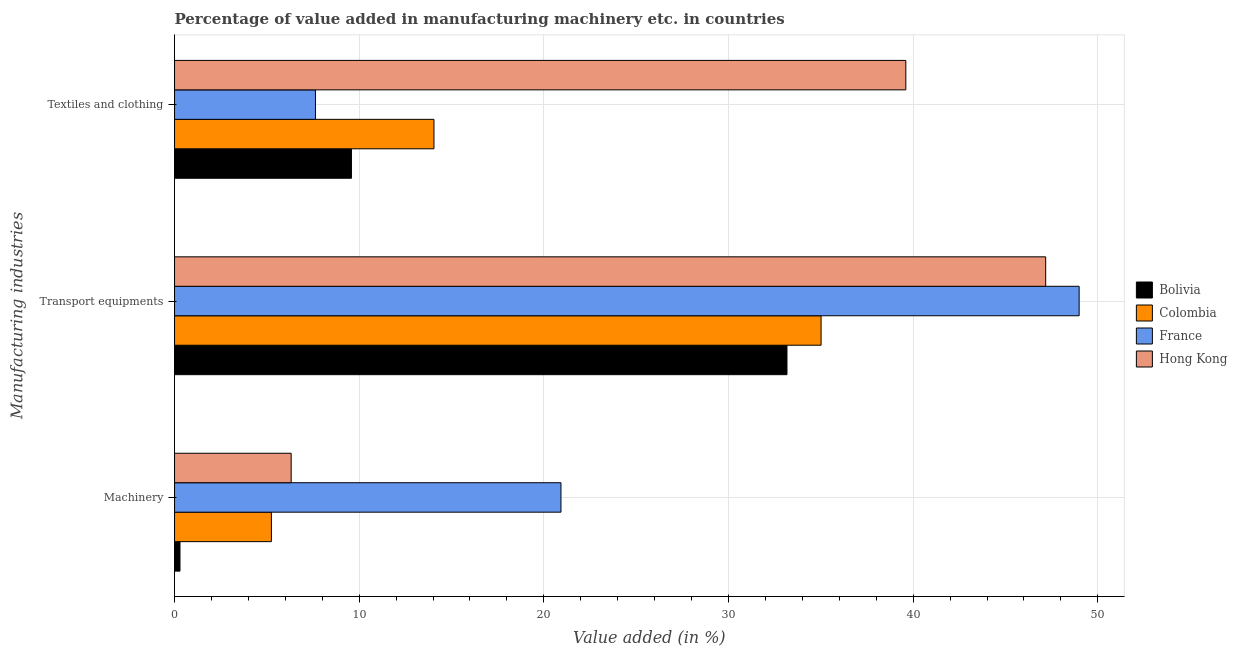How many different coloured bars are there?
Your answer should be compact. 4. How many groups of bars are there?
Your answer should be very brief. 3. How many bars are there on the 1st tick from the top?
Provide a short and direct response. 4. How many bars are there on the 1st tick from the bottom?
Make the answer very short. 4. What is the label of the 1st group of bars from the top?
Provide a short and direct response. Textiles and clothing. What is the value added in manufacturing transport equipments in France?
Give a very brief answer. 48.99. Across all countries, what is the maximum value added in manufacturing textile and clothing?
Offer a very short reply. 39.6. Across all countries, what is the minimum value added in manufacturing textile and clothing?
Give a very brief answer. 7.63. What is the total value added in manufacturing machinery in the graph?
Your response must be concise. 32.78. What is the difference between the value added in manufacturing machinery in Colombia and that in France?
Offer a very short reply. -15.68. What is the difference between the value added in manufacturing machinery in Colombia and the value added in manufacturing textile and clothing in France?
Make the answer very short. -2.39. What is the average value added in manufacturing textile and clothing per country?
Your answer should be very brief. 17.72. What is the difference between the value added in manufacturing machinery and value added in manufacturing textile and clothing in France?
Make the answer very short. 13.3. In how many countries, is the value added in manufacturing textile and clothing greater than 4 %?
Your response must be concise. 4. What is the ratio of the value added in manufacturing textile and clothing in Hong Kong to that in France?
Make the answer very short. 5.19. Is the difference between the value added in manufacturing textile and clothing in France and Colombia greater than the difference between the value added in manufacturing machinery in France and Colombia?
Give a very brief answer. No. What is the difference between the highest and the second highest value added in manufacturing transport equipments?
Give a very brief answer. 1.81. What is the difference between the highest and the lowest value added in manufacturing machinery?
Your answer should be compact. 20.63. What does the 2nd bar from the top in Machinery represents?
Your answer should be compact. France. What does the 2nd bar from the bottom in Transport equipments represents?
Give a very brief answer. Colombia. Is it the case that in every country, the sum of the value added in manufacturing machinery and value added in manufacturing transport equipments is greater than the value added in manufacturing textile and clothing?
Your response must be concise. Yes. How many bars are there?
Your response must be concise. 12. How many countries are there in the graph?
Ensure brevity in your answer.  4. What is the difference between two consecutive major ticks on the X-axis?
Your answer should be compact. 10. Does the graph contain any zero values?
Keep it short and to the point. No. Does the graph contain grids?
Provide a short and direct response. Yes. Where does the legend appear in the graph?
Keep it short and to the point. Center right. How many legend labels are there?
Offer a very short reply. 4. How are the legend labels stacked?
Offer a very short reply. Vertical. What is the title of the graph?
Give a very brief answer. Percentage of value added in manufacturing machinery etc. in countries. Does "Hong Kong" appear as one of the legend labels in the graph?
Provide a succinct answer. Yes. What is the label or title of the X-axis?
Offer a terse response. Value added (in %). What is the label or title of the Y-axis?
Your answer should be compact. Manufacturing industries. What is the Value added (in %) in Bolivia in Machinery?
Provide a short and direct response. 0.29. What is the Value added (in %) in Colombia in Machinery?
Make the answer very short. 5.24. What is the Value added (in %) of France in Machinery?
Give a very brief answer. 20.93. What is the Value added (in %) in Hong Kong in Machinery?
Give a very brief answer. 6.32. What is the Value added (in %) in Bolivia in Transport equipments?
Your answer should be compact. 33.17. What is the Value added (in %) of Colombia in Transport equipments?
Offer a terse response. 35.01. What is the Value added (in %) of France in Transport equipments?
Offer a very short reply. 48.99. What is the Value added (in %) of Hong Kong in Transport equipments?
Make the answer very short. 47.18. What is the Value added (in %) of Bolivia in Textiles and clothing?
Ensure brevity in your answer.  9.58. What is the Value added (in %) in Colombia in Textiles and clothing?
Ensure brevity in your answer.  14.05. What is the Value added (in %) in France in Textiles and clothing?
Offer a terse response. 7.63. What is the Value added (in %) in Hong Kong in Textiles and clothing?
Provide a succinct answer. 39.6. Across all Manufacturing industries, what is the maximum Value added (in %) in Bolivia?
Your response must be concise. 33.17. Across all Manufacturing industries, what is the maximum Value added (in %) in Colombia?
Offer a terse response. 35.01. Across all Manufacturing industries, what is the maximum Value added (in %) of France?
Make the answer very short. 48.99. Across all Manufacturing industries, what is the maximum Value added (in %) in Hong Kong?
Make the answer very short. 47.18. Across all Manufacturing industries, what is the minimum Value added (in %) in Bolivia?
Your answer should be compact. 0.29. Across all Manufacturing industries, what is the minimum Value added (in %) in Colombia?
Keep it short and to the point. 5.24. Across all Manufacturing industries, what is the minimum Value added (in %) in France?
Provide a short and direct response. 7.63. Across all Manufacturing industries, what is the minimum Value added (in %) in Hong Kong?
Offer a very short reply. 6.32. What is the total Value added (in %) in Bolivia in the graph?
Provide a short and direct response. 43.04. What is the total Value added (in %) in Colombia in the graph?
Keep it short and to the point. 54.31. What is the total Value added (in %) of France in the graph?
Provide a short and direct response. 77.55. What is the total Value added (in %) in Hong Kong in the graph?
Make the answer very short. 93.1. What is the difference between the Value added (in %) in Bolivia in Machinery and that in Transport equipments?
Ensure brevity in your answer.  -32.87. What is the difference between the Value added (in %) of Colombia in Machinery and that in Transport equipments?
Give a very brief answer. -29.77. What is the difference between the Value added (in %) of France in Machinery and that in Transport equipments?
Your answer should be compact. -28.06. What is the difference between the Value added (in %) of Hong Kong in Machinery and that in Transport equipments?
Provide a succinct answer. -40.86. What is the difference between the Value added (in %) of Bolivia in Machinery and that in Textiles and clothing?
Make the answer very short. -9.29. What is the difference between the Value added (in %) in Colombia in Machinery and that in Textiles and clothing?
Your answer should be compact. -8.8. What is the difference between the Value added (in %) in France in Machinery and that in Textiles and clothing?
Provide a succinct answer. 13.3. What is the difference between the Value added (in %) of Hong Kong in Machinery and that in Textiles and clothing?
Your response must be concise. -33.29. What is the difference between the Value added (in %) of Bolivia in Transport equipments and that in Textiles and clothing?
Provide a short and direct response. 23.59. What is the difference between the Value added (in %) in Colombia in Transport equipments and that in Textiles and clothing?
Provide a succinct answer. 20.96. What is the difference between the Value added (in %) of France in Transport equipments and that in Textiles and clothing?
Ensure brevity in your answer.  41.36. What is the difference between the Value added (in %) of Hong Kong in Transport equipments and that in Textiles and clothing?
Your answer should be very brief. 7.57. What is the difference between the Value added (in %) of Bolivia in Machinery and the Value added (in %) of Colombia in Transport equipments?
Offer a terse response. -34.72. What is the difference between the Value added (in %) in Bolivia in Machinery and the Value added (in %) in France in Transport equipments?
Keep it short and to the point. -48.7. What is the difference between the Value added (in %) in Bolivia in Machinery and the Value added (in %) in Hong Kong in Transport equipments?
Provide a succinct answer. -46.88. What is the difference between the Value added (in %) of Colombia in Machinery and the Value added (in %) of France in Transport equipments?
Ensure brevity in your answer.  -43.74. What is the difference between the Value added (in %) in Colombia in Machinery and the Value added (in %) in Hong Kong in Transport equipments?
Give a very brief answer. -41.93. What is the difference between the Value added (in %) in France in Machinery and the Value added (in %) in Hong Kong in Transport equipments?
Provide a short and direct response. -26.25. What is the difference between the Value added (in %) of Bolivia in Machinery and the Value added (in %) of Colombia in Textiles and clothing?
Offer a very short reply. -13.76. What is the difference between the Value added (in %) of Bolivia in Machinery and the Value added (in %) of France in Textiles and clothing?
Keep it short and to the point. -7.34. What is the difference between the Value added (in %) of Bolivia in Machinery and the Value added (in %) of Hong Kong in Textiles and clothing?
Offer a very short reply. -39.31. What is the difference between the Value added (in %) in Colombia in Machinery and the Value added (in %) in France in Textiles and clothing?
Make the answer very short. -2.39. What is the difference between the Value added (in %) in Colombia in Machinery and the Value added (in %) in Hong Kong in Textiles and clothing?
Provide a short and direct response. -34.36. What is the difference between the Value added (in %) of France in Machinery and the Value added (in %) of Hong Kong in Textiles and clothing?
Offer a very short reply. -18.68. What is the difference between the Value added (in %) in Bolivia in Transport equipments and the Value added (in %) in Colombia in Textiles and clothing?
Your response must be concise. 19.12. What is the difference between the Value added (in %) in Bolivia in Transport equipments and the Value added (in %) in France in Textiles and clothing?
Provide a short and direct response. 25.54. What is the difference between the Value added (in %) in Bolivia in Transport equipments and the Value added (in %) in Hong Kong in Textiles and clothing?
Keep it short and to the point. -6.44. What is the difference between the Value added (in %) in Colombia in Transport equipments and the Value added (in %) in France in Textiles and clothing?
Your answer should be compact. 27.38. What is the difference between the Value added (in %) in Colombia in Transport equipments and the Value added (in %) in Hong Kong in Textiles and clothing?
Your answer should be compact. -4.59. What is the difference between the Value added (in %) in France in Transport equipments and the Value added (in %) in Hong Kong in Textiles and clothing?
Keep it short and to the point. 9.39. What is the average Value added (in %) in Bolivia per Manufacturing industries?
Your response must be concise. 14.35. What is the average Value added (in %) of Colombia per Manufacturing industries?
Ensure brevity in your answer.  18.1. What is the average Value added (in %) in France per Manufacturing industries?
Your answer should be very brief. 25.85. What is the average Value added (in %) of Hong Kong per Manufacturing industries?
Keep it short and to the point. 31.03. What is the difference between the Value added (in %) of Bolivia and Value added (in %) of Colombia in Machinery?
Your answer should be compact. -4.95. What is the difference between the Value added (in %) in Bolivia and Value added (in %) in France in Machinery?
Offer a very short reply. -20.63. What is the difference between the Value added (in %) in Bolivia and Value added (in %) in Hong Kong in Machinery?
Provide a short and direct response. -6.02. What is the difference between the Value added (in %) in Colombia and Value added (in %) in France in Machinery?
Give a very brief answer. -15.68. What is the difference between the Value added (in %) in Colombia and Value added (in %) in Hong Kong in Machinery?
Provide a succinct answer. -1.07. What is the difference between the Value added (in %) of France and Value added (in %) of Hong Kong in Machinery?
Keep it short and to the point. 14.61. What is the difference between the Value added (in %) in Bolivia and Value added (in %) in Colombia in Transport equipments?
Keep it short and to the point. -1.85. What is the difference between the Value added (in %) in Bolivia and Value added (in %) in France in Transport equipments?
Make the answer very short. -15.82. What is the difference between the Value added (in %) in Bolivia and Value added (in %) in Hong Kong in Transport equipments?
Keep it short and to the point. -14.01. What is the difference between the Value added (in %) of Colombia and Value added (in %) of France in Transport equipments?
Give a very brief answer. -13.98. What is the difference between the Value added (in %) of Colombia and Value added (in %) of Hong Kong in Transport equipments?
Give a very brief answer. -12.16. What is the difference between the Value added (in %) in France and Value added (in %) in Hong Kong in Transport equipments?
Offer a very short reply. 1.81. What is the difference between the Value added (in %) in Bolivia and Value added (in %) in Colombia in Textiles and clothing?
Offer a terse response. -4.47. What is the difference between the Value added (in %) in Bolivia and Value added (in %) in France in Textiles and clothing?
Make the answer very short. 1.95. What is the difference between the Value added (in %) in Bolivia and Value added (in %) in Hong Kong in Textiles and clothing?
Provide a succinct answer. -30.02. What is the difference between the Value added (in %) in Colombia and Value added (in %) in France in Textiles and clothing?
Ensure brevity in your answer.  6.42. What is the difference between the Value added (in %) in Colombia and Value added (in %) in Hong Kong in Textiles and clothing?
Ensure brevity in your answer.  -25.55. What is the difference between the Value added (in %) of France and Value added (in %) of Hong Kong in Textiles and clothing?
Give a very brief answer. -31.97. What is the ratio of the Value added (in %) in Bolivia in Machinery to that in Transport equipments?
Provide a succinct answer. 0.01. What is the ratio of the Value added (in %) of Colombia in Machinery to that in Transport equipments?
Offer a very short reply. 0.15. What is the ratio of the Value added (in %) in France in Machinery to that in Transport equipments?
Provide a short and direct response. 0.43. What is the ratio of the Value added (in %) of Hong Kong in Machinery to that in Transport equipments?
Offer a terse response. 0.13. What is the ratio of the Value added (in %) of Bolivia in Machinery to that in Textiles and clothing?
Offer a terse response. 0.03. What is the ratio of the Value added (in %) in Colombia in Machinery to that in Textiles and clothing?
Make the answer very short. 0.37. What is the ratio of the Value added (in %) in France in Machinery to that in Textiles and clothing?
Keep it short and to the point. 2.74. What is the ratio of the Value added (in %) in Hong Kong in Machinery to that in Textiles and clothing?
Provide a succinct answer. 0.16. What is the ratio of the Value added (in %) in Bolivia in Transport equipments to that in Textiles and clothing?
Ensure brevity in your answer.  3.46. What is the ratio of the Value added (in %) in Colombia in Transport equipments to that in Textiles and clothing?
Make the answer very short. 2.49. What is the ratio of the Value added (in %) in France in Transport equipments to that in Textiles and clothing?
Your answer should be very brief. 6.42. What is the ratio of the Value added (in %) in Hong Kong in Transport equipments to that in Textiles and clothing?
Offer a terse response. 1.19. What is the difference between the highest and the second highest Value added (in %) of Bolivia?
Ensure brevity in your answer.  23.59. What is the difference between the highest and the second highest Value added (in %) in Colombia?
Give a very brief answer. 20.96. What is the difference between the highest and the second highest Value added (in %) of France?
Make the answer very short. 28.06. What is the difference between the highest and the second highest Value added (in %) of Hong Kong?
Offer a very short reply. 7.57. What is the difference between the highest and the lowest Value added (in %) of Bolivia?
Provide a short and direct response. 32.87. What is the difference between the highest and the lowest Value added (in %) of Colombia?
Make the answer very short. 29.77. What is the difference between the highest and the lowest Value added (in %) in France?
Give a very brief answer. 41.36. What is the difference between the highest and the lowest Value added (in %) of Hong Kong?
Provide a short and direct response. 40.86. 